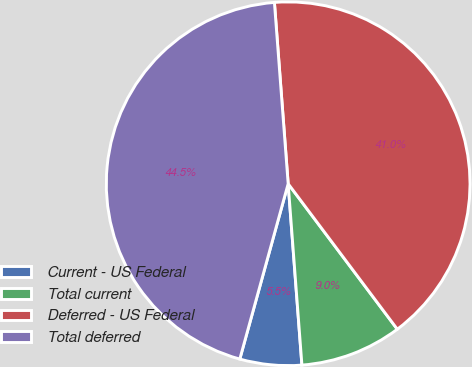<chart> <loc_0><loc_0><loc_500><loc_500><pie_chart><fcel>Current - US Federal<fcel>Total current<fcel>Deferred - US Federal<fcel>Total deferred<nl><fcel>5.49%<fcel>9.04%<fcel>40.96%<fcel>44.51%<nl></chart> 